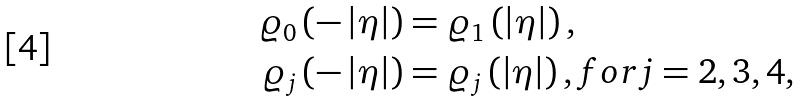<formula> <loc_0><loc_0><loc_500><loc_500>\varrho _ { 0 } \left ( - \left | \eta \right | \right ) & = \varrho _ { 1 } \left ( \left | \eta \right | \right ) , \\ \varrho _ { j } \left ( - \left | \eta \right | \right ) & = \varrho _ { j } \left ( \left | \eta \right | \right ) , f o r j = 2 , 3 , 4 ,</formula> 